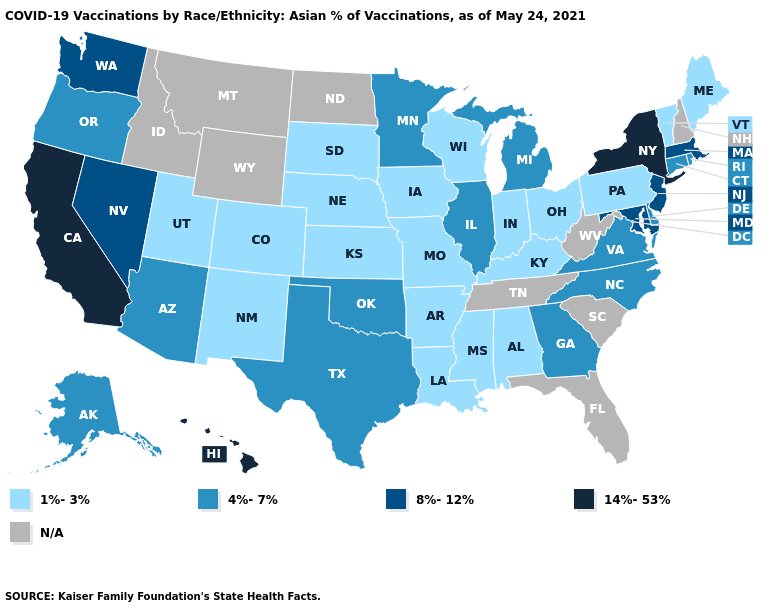What is the value of Virginia?
Keep it brief. 4%-7%. What is the value of Vermont?
Quick response, please. 1%-3%. Does Wisconsin have the highest value in the USA?
Write a very short answer. No. What is the value of North Carolina?
Write a very short answer. 4%-7%. What is the value of Idaho?
Quick response, please. N/A. Does California have the highest value in the USA?
Give a very brief answer. Yes. Name the states that have a value in the range 8%-12%?
Answer briefly. Maryland, Massachusetts, Nevada, New Jersey, Washington. Name the states that have a value in the range N/A?
Quick response, please. Florida, Idaho, Montana, New Hampshire, North Dakota, South Carolina, Tennessee, West Virginia, Wyoming. Among the states that border Oklahoma , does Texas have the lowest value?
Give a very brief answer. No. How many symbols are there in the legend?
Concise answer only. 5. What is the value of West Virginia?
Quick response, please. N/A. Does the first symbol in the legend represent the smallest category?
Short answer required. Yes. Name the states that have a value in the range 14%-53%?
Be succinct. California, Hawaii, New York. 